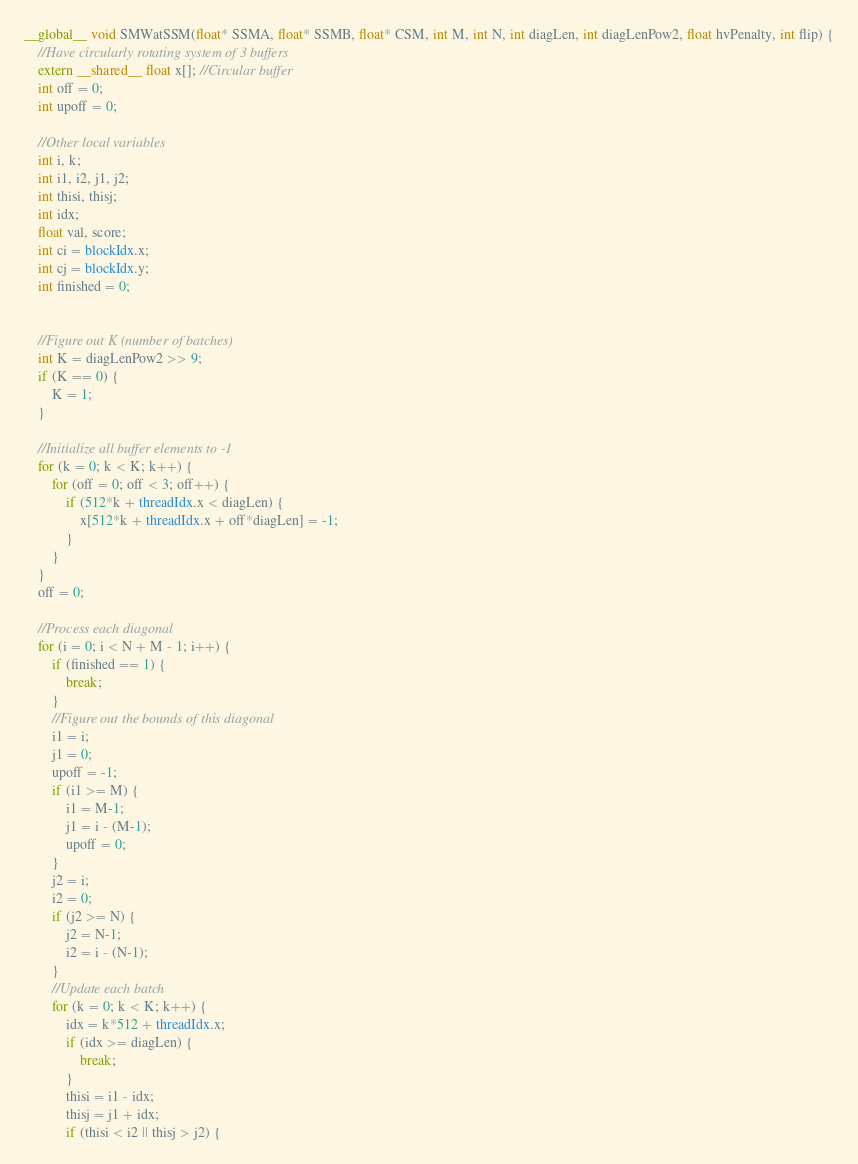<code> <loc_0><loc_0><loc_500><loc_500><_Cuda_>__global__ void SMWatSSM(float* SSMA, float* SSMB, float* CSM, int M, int N, int diagLen, int diagLenPow2, float hvPenalty, int flip) {
    //Have circularly rotating system of 3 buffers
    extern __shared__ float x[]; //Circular buffer
    int off = 0;
    int upoff = 0;

    //Other local variables
    int i, k;
    int i1, i2, j1, j2;
    int thisi, thisj;
    int idx;
    float val, score;
    int ci = blockIdx.x;
    int cj = blockIdx.y;
    int finished = 0;


    //Figure out K (number of batches)
    int K = diagLenPow2 >> 9;
    if (K == 0) {
        K = 1;
    }

    //Initialize all buffer elements to -1
    for (k = 0; k < K; k++) {
        for (off = 0; off < 3; off++) {
            if (512*k + threadIdx.x < diagLen) {
                x[512*k + threadIdx.x + off*diagLen] = -1;
            }
        }
    }
    off = 0;

    //Process each diagonal
    for (i = 0; i < N + M - 1; i++) {
        if (finished == 1) {
            break;
        }
        //Figure out the bounds of this diagonal
        i1 = i;
        j1 = 0;
        upoff = -1;
        if (i1 >= M) {
            i1 = M-1;
            j1 = i - (M-1);
            upoff = 0;
        }
        j2 = i;
        i2 = 0;
        if (j2 >= N) {
            j2 = N-1;
            i2 = i - (N-1);
        }
        //Update each batch
        for (k = 0; k < K; k++) {
            idx = k*512 + threadIdx.x;
            if (idx >= diagLen) {
                break;
            }
            thisi = i1 - idx;
            thisj = j1 + idx;
            if (thisi < i2 || thisj > j2) {</code> 